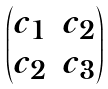<formula> <loc_0><loc_0><loc_500><loc_500>\begin{pmatrix} c _ { 1 } & c _ { 2 } \\ c _ { 2 } & c _ { 3 } \end{pmatrix}</formula> 